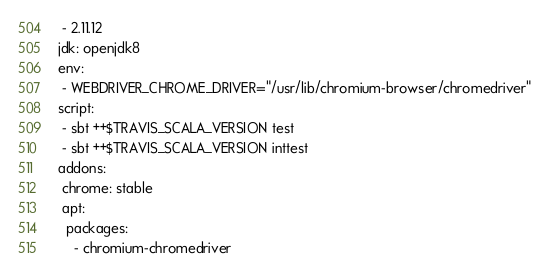<code> <loc_0><loc_0><loc_500><loc_500><_YAML_> - 2.11.12
jdk: openjdk8
env:
 - WEBDRIVER_CHROME_DRIVER="/usr/lib/chromium-browser/chromedriver"
script:
 - sbt ++$TRAVIS_SCALA_VERSION test
 - sbt ++$TRAVIS_SCALA_VERSION inttest
addons:
 chrome: stable
 apt:
  packages:
    - chromium-chromedriver
</code> 